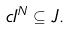<formula> <loc_0><loc_0><loc_500><loc_500>c I ^ { N } \subseteq J .</formula> 